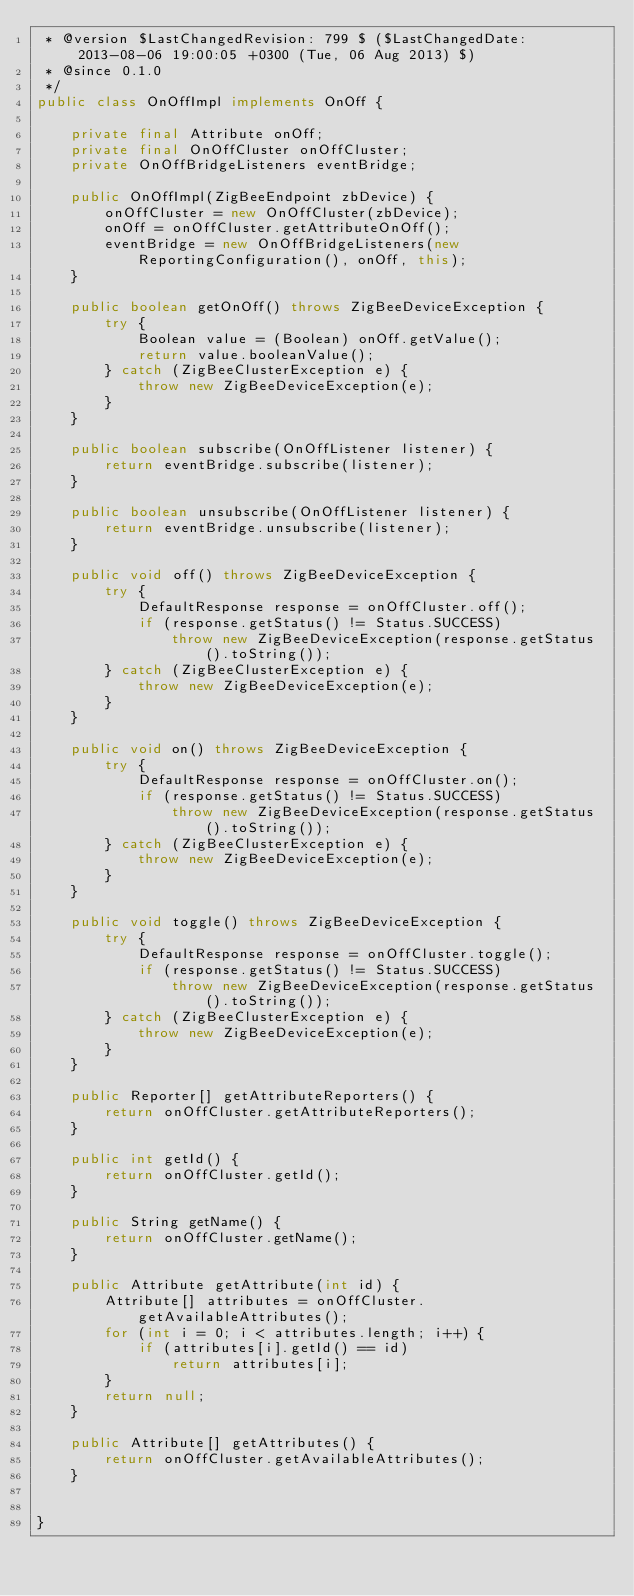Convert code to text. <code><loc_0><loc_0><loc_500><loc_500><_Java_> * @version $LastChangedRevision: 799 $ ($LastChangedDate: 2013-08-06 19:00:05 +0300 (Tue, 06 Aug 2013) $)
 * @since 0.1.0
 */
public class OnOffImpl implements OnOff {

    private final Attribute onOff;
    private final OnOffCluster onOffCluster;
    private OnOffBridgeListeners eventBridge;

    public OnOffImpl(ZigBeeEndpoint zbDevice) {
        onOffCluster = new OnOffCluster(zbDevice);
        onOff = onOffCluster.getAttributeOnOff();
        eventBridge = new OnOffBridgeListeners(new ReportingConfiguration(), onOff, this);
    }

    public boolean getOnOff() throws ZigBeeDeviceException {
        try {
            Boolean value = (Boolean) onOff.getValue();
            return value.booleanValue();
        } catch (ZigBeeClusterException e) {
            throw new ZigBeeDeviceException(e);
        }
    }

    public boolean subscribe(OnOffListener listener) {
        return eventBridge.subscribe(listener);
    }

    public boolean unsubscribe(OnOffListener listener) {
        return eventBridge.unsubscribe(listener);
    }

    public void off() throws ZigBeeDeviceException {
        try {
            DefaultResponse response = onOffCluster.off();
            if (response.getStatus() != Status.SUCCESS)
                throw new ZigBeeDeviceException(response.getStatus().toString());
        } catch (ZigBeeClusterException e) {
            throw new ZigBeeDeviceException(e);
        }
    }

    public void on() throws ZigBeeDeviceException {
        try {
            DefaultResponse response = onOffCluster.on();
            if (response.getStatus() != Status.SUCCESS)
                throw new ZigBeeDeviceException(response.getStatus().toString());
        } catch (ZigBeeClusterException e) {
            throw new ZigBeeDeviceException(e);
        }
    }

    public void toggle() throws ZigBeeDeviceException {
        try {
            DefaultResponse response = onOffCluster.toggle();
            if (response.getStatus() != Status.SUCCESS)
                throw new ZigBeeDeviceException(response.getStatus().toString());
        } catch (ZigBeeClusterException e) {
            throw new ZigBeeDeviceException(e);
        }
    }

    public Reporter[] getAttributeReporters() {
        return onOffCluster.getAttributeReporters();
    }

    public int getId() {
        return onOffCluster.getId();
    }

    public String getName() {
        return onOffCluster.getName();
    }

    public Attribute getAttribute(int id) {
        Attribute[] attributes = onOffCluster.getAvailableAttributes();
        for (int i = 0; i < attributes.length; i++) {
            if (attributes[i].getId() == id)
                return attributes[i];
        }
        return null;
    }

    public Attribute[] getAttributes() {
        return onOffCluster.getAvailableAttributes();
    }


}
</code> 